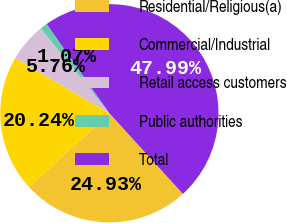Convert chart. <chart><loc_0><loc_0><loc_500><loc_500><pie_chart><fcel>Residential/Religious(a)<fcel>Commercial/Industrial<fcel>Retail access customers<fcel>Public authorities<fcel>Total<nl><fcel>24.93%<fcel>20.24%<fcel>5.76%<fcel>1.07%<fcel>47.99%<nl></chart> 